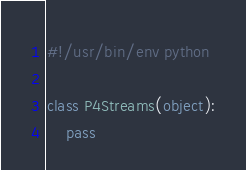<code> <loc_0><loc_0><loc_500><loc_500><_Python_>#!/usr/bin/env python

class P4Streams(object):
    pass
</code> 